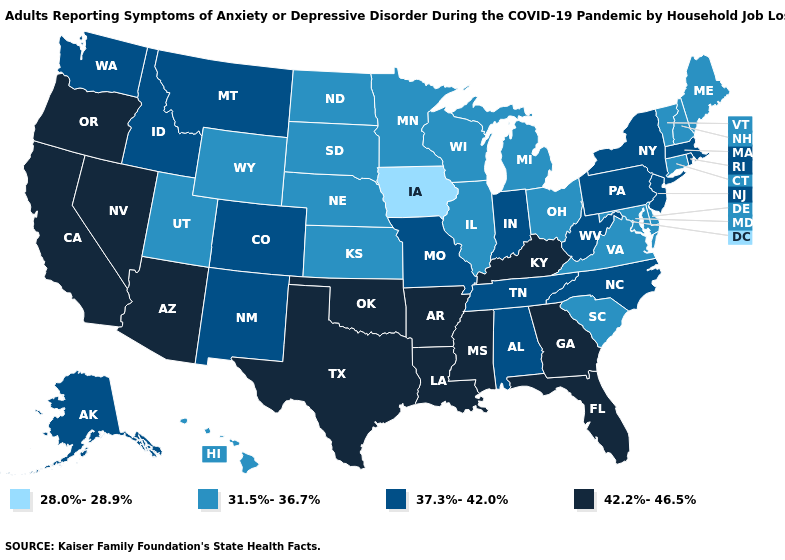What is the value of Utah?
Write a very short answer. 31.5%-36.7%. Does West Virginia have a lower value than North Carolina?
Give a very brief answer. No. Which states have the lowest value in the USA?
Quick response, please. Iowa. What is the highest value in states that border Vermont?
Write a very short answer. 37.3%-42.0%. What is the lowest value in states that border New Hampshire?
Concise answer only. 31.5%-36.7%. Name the states that have a value in the range 42.2%-46.5%?
Be succinct. Arizona, Arkansas, California, Florida, Georgia, Kentucky, Louisiana, Mississippi, Nevada, Oklahoma, Oregon, Texas. What is the highest value in the USA?
Keep it brief. 42.2%-46.5%. What is the lowest value in states that border Oklahoma?
Concise answer only. 31.5%-36.7%. Does Ohio have a lower value than North Dakota?
Answer briefly. No. Does the first symbol in the legend represent the smallest category?
Short answer required. Yes. What is the highest value in states that border Oregon?
Quick response, please. 42.2%-46.5%. Which states have the lowest value in the USA?
Short answer required. Iowa. Which states hav the highest value in the Northeast?
Concise answer only. Massachusetts, New Jersey, New York, Pennsylvania, Rhode Island. Name the states that have a value in the range 42.2%-46.5%?
Concise answer only. Arizona, Arkansas, California, Florida, Georgia, Kentucky, Louisiana, Mississippi, Nevada, Oklahoma, Oregon, Texas. 